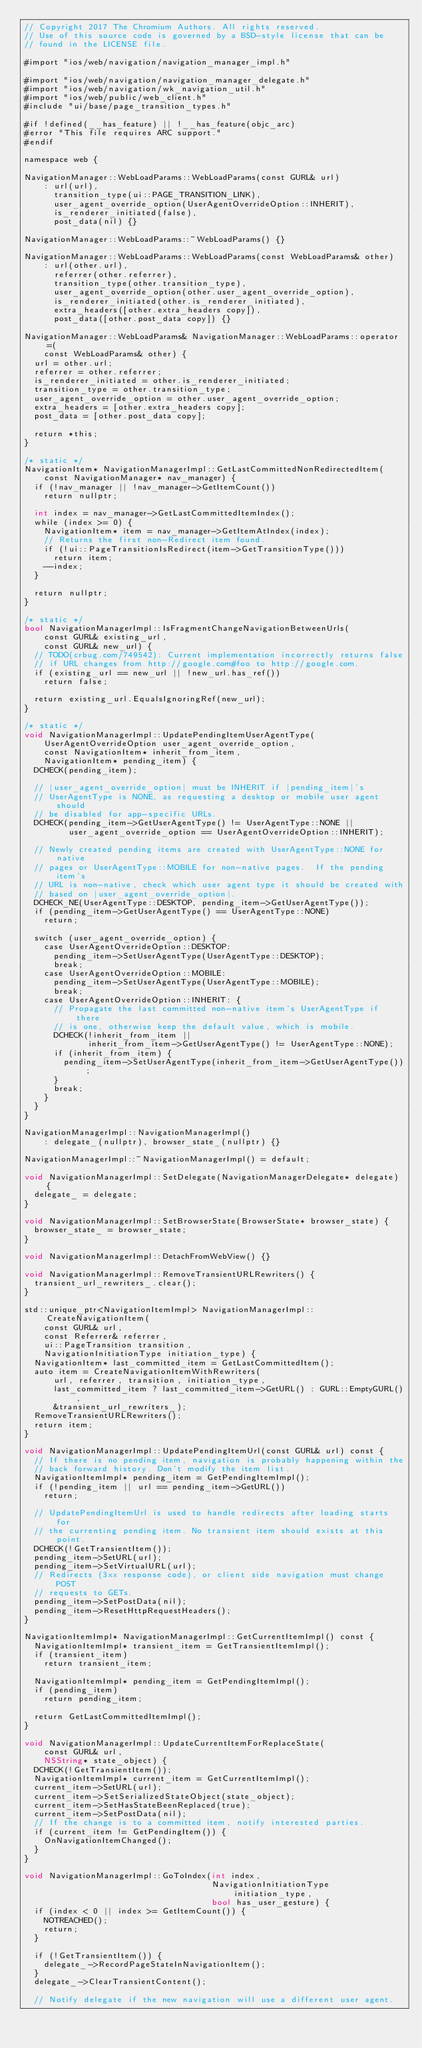<code> <loc_0><loc_0><loc_500><loc_500><_ObjectiveC_>// Copyright 2017 The Chromium Authors. All rights reserved.
// Use of this source code is governed by a BSD-style license that can be
// found in the LICENSE file.

#import "ios/web/navigation/navigation_manager_impl.h"

#import "ios/web/navigation/navigation_manager_delegate.h"
#import "ios/web/navigation/wk_navigation_util.h"
#import "ios/web/public/web_client.h"
#include "ui/base/page_transition_types.h"

#if !defined(__has_feature) || !__has_feature(objc_arc)
#error "This file requires ARC support."
#endif

namespace web {

NavigationManager::WebLoadParams::WebLoadParams(const GURL& url)
    : url(url),
      transition_type(ui::PAGE_TRANSITION_LINK),
      user_agent_override_option(UserAgentOverrideOption::INHERIT),
      is_renderer_initiated(false),
      post_data(nil) {}

NavigationManager::WebLoadParams::~WebLoadParams() {}

NavigationManager::WebLoadParams::WebLoadParams(const WebLoadParams& other)
    : url(other.url),
      referrer(other.referrer),
      transition_type(other.transition_type),
      user_agent_override_option(other.user_agent_override_option),
      is_renderer_initiated(other.is_renderer_initiated),
      extra_headers([other.extra_headers copy]),
      post_data([other.post_data copy]) {}

NavigationManager::WebLoadParams& NavigationManager::WebLoadParams::operator=(
    const WebLoadParams& other) {
  url = other.url;
  referrer = other.referrer;
  is_renderer_initiated = other.is_renderer_initiated;
  transition_type = other.transition_type;
  user_agent_override_option = other.user_agent_override_option;
  extra_headers = [other.extra_headers copy];
  post_data = [other.post_data copy];

  return *this;
}

/* static */
NavigationItem* NavigationManagerImpl::GetLastCommittedNonRedirectedItem(
    const NavigationManager* nav_manager) {
  if (!nav_manager || !nav_manager->GetItemCount())
    return nullptr;

  int index = nav_manager->GetLastCommittedItemIndex();
  while (index >= 0) {
    NavigationItem* item = nav_manager->GetItemAtIndex(index);
    // Returns the first non-Redirect item found.
    if (!ui::PageTransitionIsRedirect(item->GetTransitionType()))
      return item;
    --index;
  }

  return nullptr;
}

/* static */
bool NavigationManagerImpl::IsFragmentChangeNavigationBetweenUrls(
    const GURL& existing_url,
    const GURL& new_url) {
  // TODO(crbug.com/749542): Current implementation incorrectly returns false
  // if URL changes from http://google.com#foo to http://google.com.
  if (existing_url == new_url || !new_url.has_ref())
    return false;

  return existing_url.EqualsIgnoringRef(new_url);
}

/* static */
void NavigationManagerImpl::UpdatePendingItemUserAgentType(
    UserAgentOverrideOption user_agent_override_option,
    const NavigationItem* inherit_from_item,
    NavigationItem* pending_item) {
  DCHECK(pending_item);

  // |user_agent_override_option| must be INHERIT if |pending_item|'s
  // UserAgentType is NONE, as requesting a desktop or mobile user agent should
  // be disabled for app-specific URLs.
  DCHECK(pending_item->GetUserAgentType() != UserAgentType::NONE ||
         user_agent_override_option == UserAgentOverrideOption::INHERIT);

  // Newly created pending items are created with UserAgentType::NONE for native
  // pages or UserAgentType::MOBILE for non-native pages.  If the pending item's
  // URL is non-native, check which user agent type it should be created with
  // based on |user_agent_override_option|.
  DCHECK_NE(UserAgentType::DESKTOP, pending_item->GetUserAgentType());
  if (pending_item->GetUserAgentType() == UserAgentType::NONE)
    return;

  switch (user_agent_override_option) {
    case UserAgentOverrideOption::DESKTOP:
      pending_item->SetUserAgentType(UserAgentType::DESKTOP);
      break;
    case UserAgentOverrideOption::MOBILE:
      pending_item->SetUserAgentType(UserAgentType::MOBILE);
      break;
    case UserAgentOverrideOption::INHERIT: {
      // Propagate the last committed non-native item's UserAgentType if there
      // is one, otherwise keep the default value, which is mobile.
      DCHECK(!inherit_from_item ||
             inherit_from_item->GetUserAgentType() != UserAgentType::NONE);
      if (inherit_from_item) {
        pending_item->SetUserAgentType(inherit_from_item->GetUserAgentType());
      }
      break;
    }
  }
}

NavigationManagerImpl::NavigationManagerImpl()
    : delegate_(nullptr), browser_state_(nullptr) {}

NavigationManagerImpl::~NavigationManagerImpl() = default;

void NavigationManagerImpl::SetDelegate(NavigationManagerDelegate* delegate) {
  delegate_ = delegate;
}

void NavigationManagerImpl::SetBrowserState(BrowserState* browser_state) {
  browser_state_ = browser_state;
}

void NavigationManagerImpl::DetachFromWebView() {}

void NavigationManagerImpl::RemoveTransientURLRewriters() {
  transient_url_rewriters_.clear();
}

std::unique_ptr<NavigationItemImpl> NavigationManagerImpl::CreateNavigationItem(
    const GURL& url,
    const Referrer& referrer,
    ui::PageTransition transition,
    NavigationInitiationType initiation_type) {
  NavigationItem* last_committed_item = GetLastCommittedItem();
  auto item = CreateNavigationItemWithRewriters(
      url, referrer, transition, initiation_type,
      last_committed_item ? last_committed_item->GetURL() : GURL::EmptyGURL(),
      &transient_url_rewriters_);
  RemoveTransientURLRewriters();
  return item;
}

void NavigationManagerImpl::UpdatePendingItemUrl(const GURL& url) const {
  // If there is no pending item, navigation is probably happening within the
  // back forward history. Don't modify the item list.
  NavigationItemImpl* pending_item = GetPendingItemImpl();
  if (!pending_item || url == pending_item->GetURL())
    return;

  // UpdatePendingItemUrl is used to handle redirects after loading starts for
  // the currenting pending item. No transient item should exists at this point.
  DCHECK(!GetTransientItem());
  pending_item->SetURL(url);
  pending_item->SetVirtualURL(url);
  // Redirects (3xx response code), or client side navigation must change POST
  // requests to GETs.
  pending_item->SetPostData(nil);
  pending_item->ResetHttpRequestHeaders();
}

NavigationItemImpl* NavigationManagerImpl::GetCurrentItemImpl() const {
  NavigationItemImpl* transient_item = GetTransientItemImpl();
  if (transient_item)
    return transient_item;

  NavigationItemImpl* pending_item = GetPendingItemImpl();
  if (pending_item)
    return pending_item;

  return GetLastCommittedItemImpl();
}

void NavigationManagerImpl::UpdateCurrentItemForReplaceState(
    const GURL& url,
    NSString* state_object) {
  DCHECK(!GetTransientItem());
  NavigationItemImpl* current_item = GetCurrentItemImpl();
  current_item->SetURL(url);
  current_item->SetSerializedStateObject(state_object);
  current_item->SetHasStateBeenReplaced(true);
  current_item->SetPostData(nil);
  // If the change is to a committed item, notify interested parties.
  if (current_item != GetPendingItem()) {
    OnNavigationItemChanged();
  }
}

void NavigationManagerImpl::GoToIndex(int index,
                                      NavigationInitiationType initiation_type,
                                      bool has_user_gesture) {
  if (index < 0 || index >= GetItemCount()) {
    NOTREACHED();
    return;
  }

  if (!GetTransientItem()) {
    delegate_->RecordPageStateInNavigationItem();
  }
  delegate_->ClearTransientContent();

  // Notify delegate if the new navigation will use a different user agent.</code> 